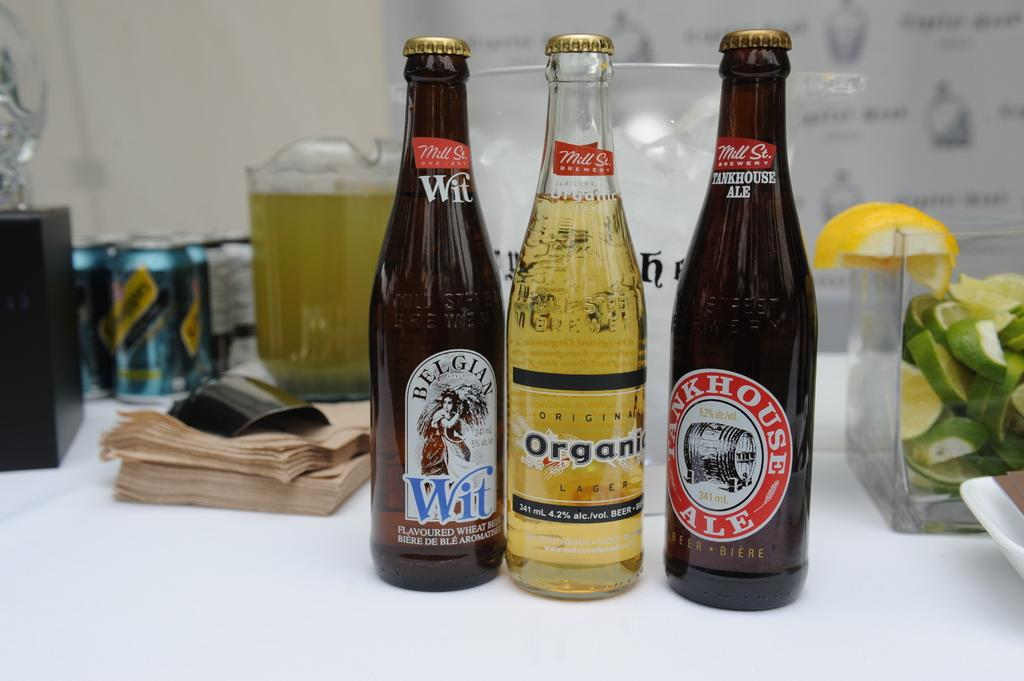Provide a one-sentence caption for the provided image. A bottle of belgian wheat ale, organic lager, and bunkhouse ale lined up on a table. 